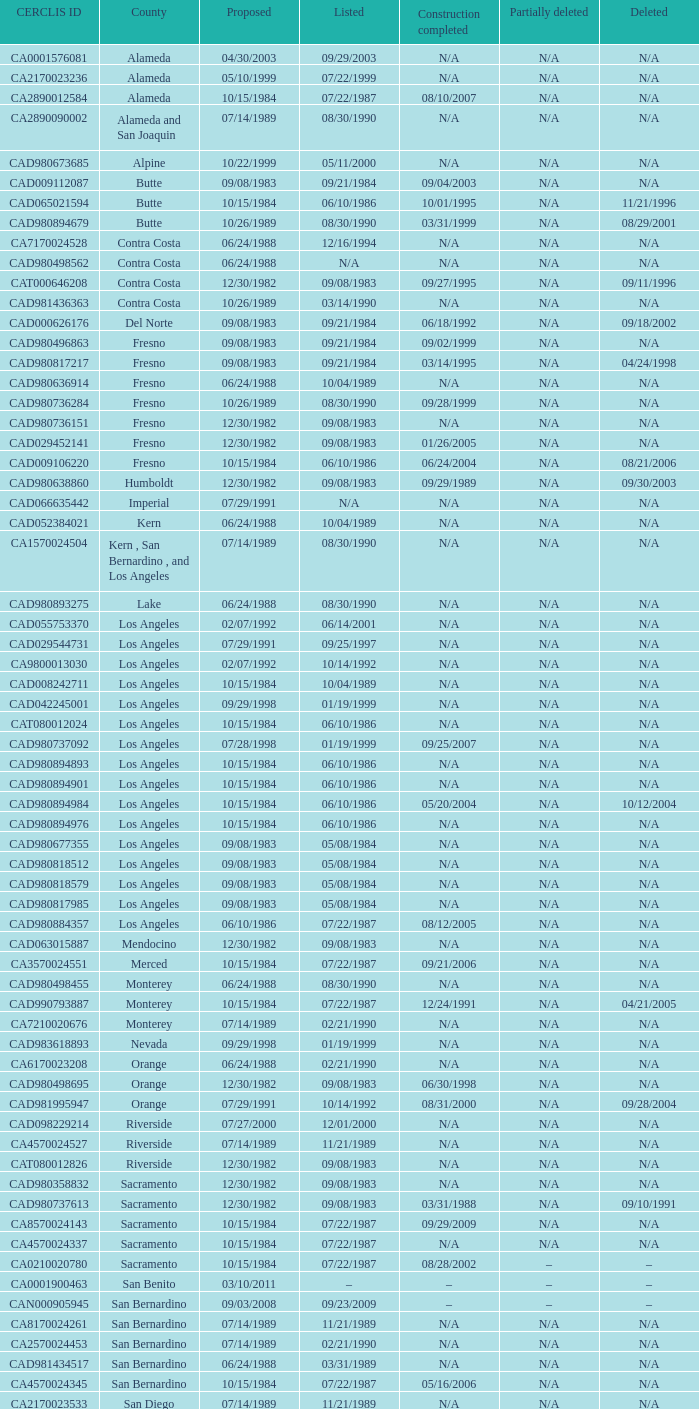What edifice was accomplished on 08/10/2007? 07/22/1987. 